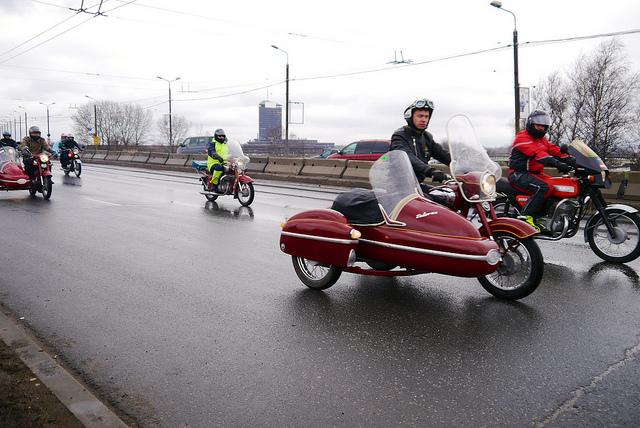What is the weather like?
Give a very brief answer. Rainy. Is this a motorbike?
Short answer required. Yes. Why are there electric lines crisscrossing the road?
Write a very short answer. Yes. 